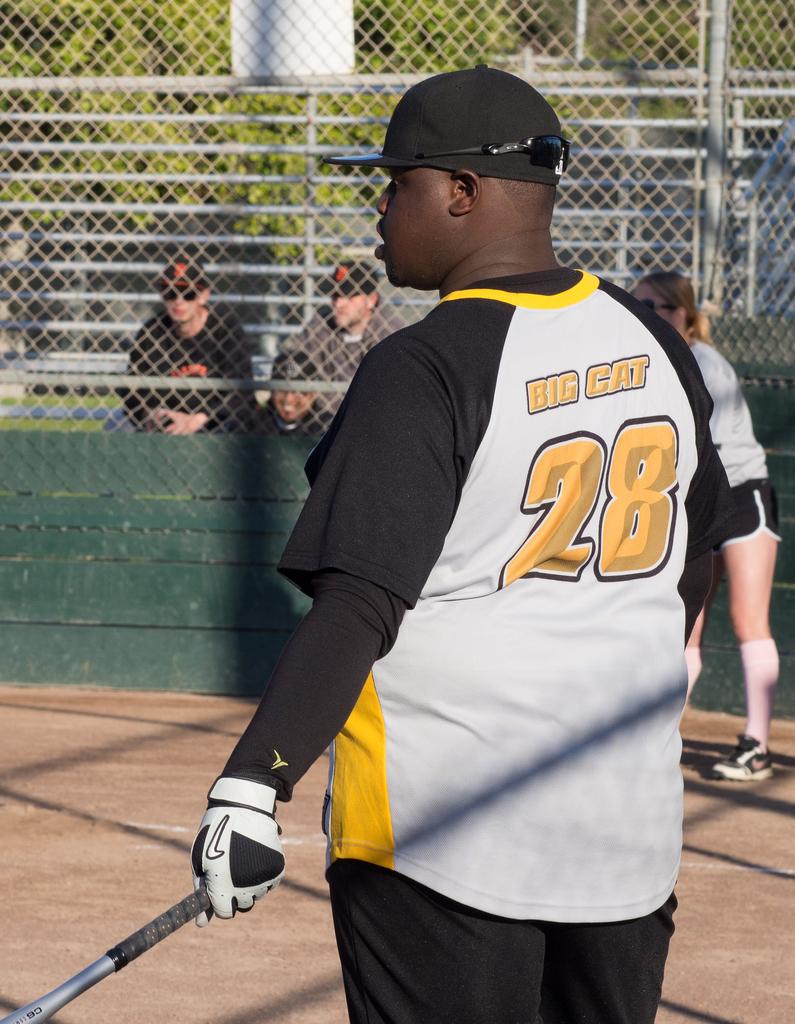What is the team this man plays for?
Give a very brief answer. Big cat. 